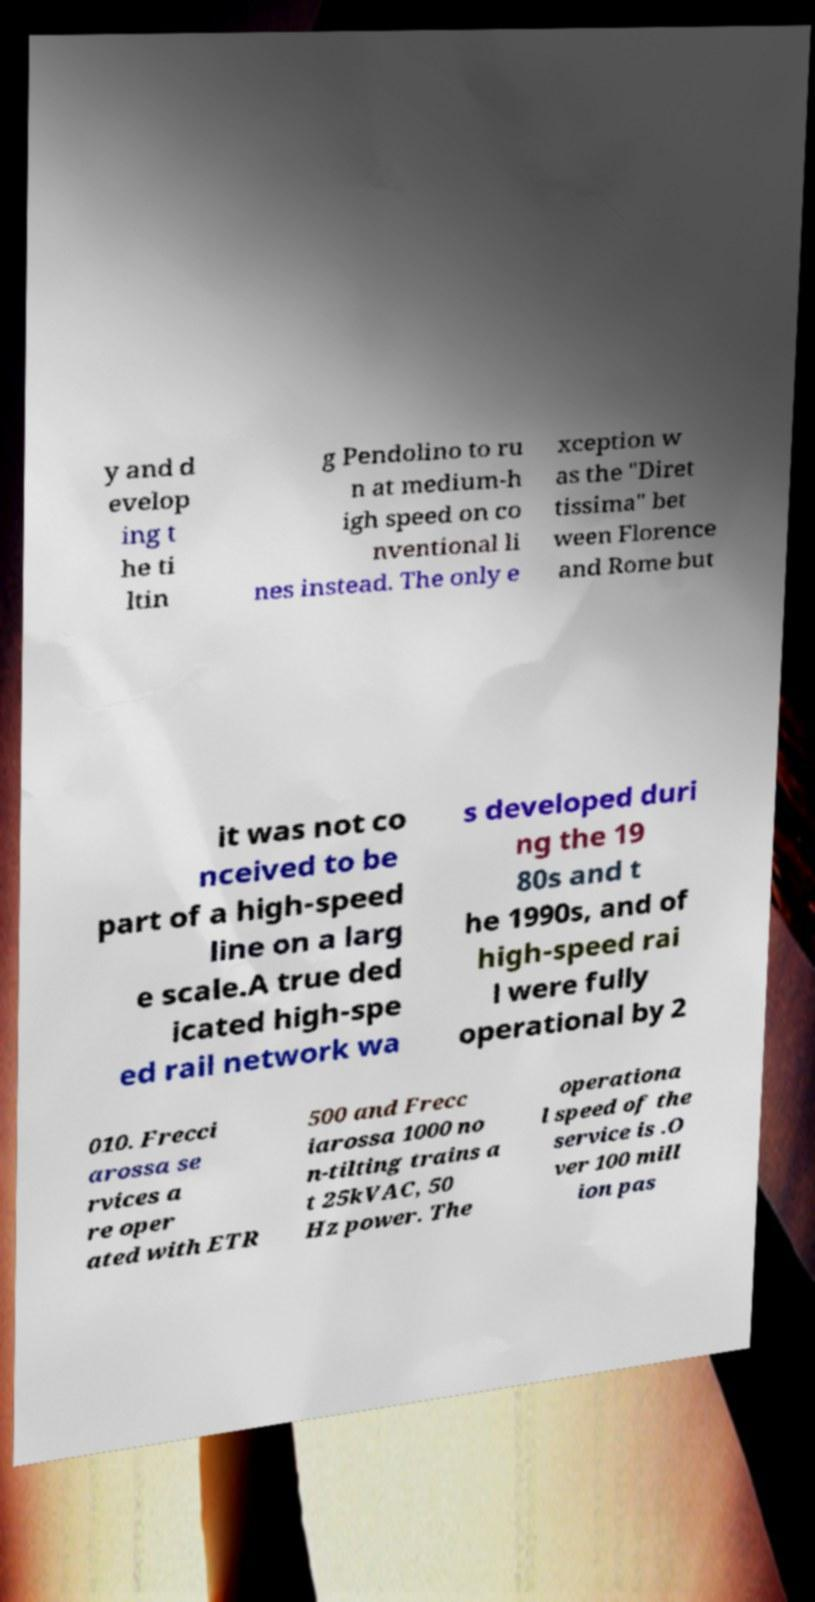There's text embedded in this image that I need extracted. Can you transcribe it verbatim? y and d evelop ing t he ti ltin g Pendolino to ru n at medium-h igh speed on co nventional li nes instead. The only e xception w as the "Diret tissima" bet ween Florence and Rome but it was not co nceived to be part of a high-speed line on a larg e scale.A true ded icated high-spe ed rail network wa s developed duri ng the 19 80s and t he 1990s, and of high-speed rai l were fully operational by 2 010. Frecci arossa se rvices a re oper ated with ETR 500 and Frecc iarossa 1000 no n-tilting trains a t 25kVAC, 50 Hz power. The operationa l speed of the service is .O ver 100 mill ion pas 